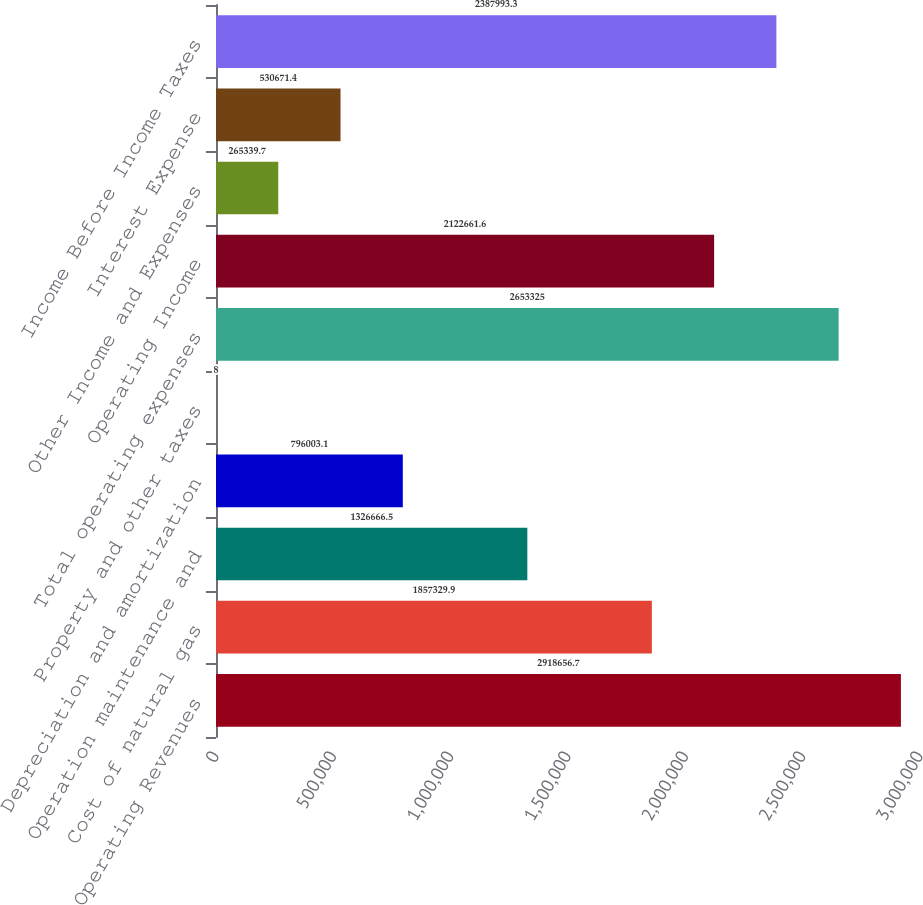<chart> <loc_0><loc_0><loc_500><loc_500><bar_chart><fcel>Operating Revenues<fcel>Cost of natural gas<fcel>Operation maintenance and<fcel>Depreciation and amortization<fcel>Property and other taxes<fcel>Total operating expenses<fcel>Operating Income<fcel>Other Income and Expenses<fcel>Interest Expense<fcel>Income Before Income Taxes<nl><fcel>2.91866e+06<fcel>1.85733e+06<fcel>1.32667e+06<fcel>796003<fcel>8<fcel>2.65332e+06<fcel>2.12266e+06<fcel>265340<fcel>530671<fcel>2.38799e+06<nl></chart> 